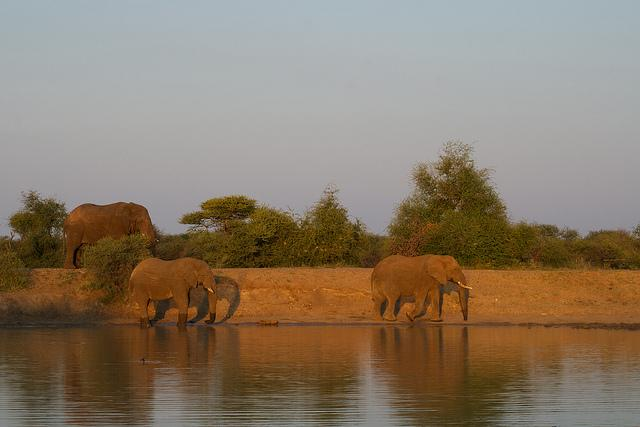What direction are the elephants facing?

Choices:
A) down
B) right
C) left
D) up right 